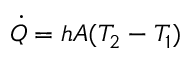<formula> <loc_0><loc_0><loc_500><loc_500>{ \dot { Q } } = h A ( T _ { 2 } - T _ { 1 } )</formula> 